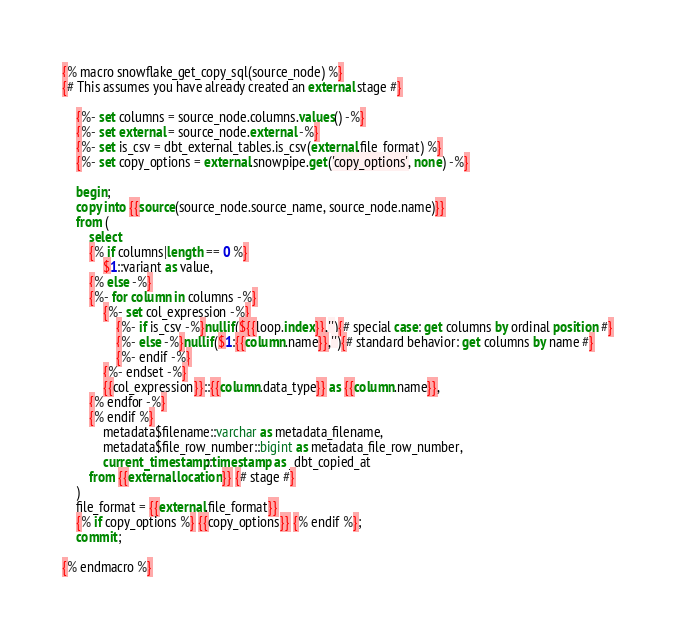<code> <loc_0><loc_0><loc_500><loc_500><_SQL_>{% macro snowflake_get_copy_sql(source_node) %}
{# This assumes you have already created an external stage #}

    {%- set columns = source_node.columns.values() -%}
    {%- set external = source_node.external -%}
    {%- set is_csv = dbt_external_tables.is_csv(external.file_format) %}
    {%- set copy_options = external.snowpipe.get('copy_options', none) -%}
    
    begin;
    copy into {{source(source_node.source_name, source_node.name)}}
    from ( 
        select
        {% if columns|length == 0 %}
            $1::variant as value,
        {% else -%}
        {%- for column in columns -%}
            {%- set col_expression -%}
                {%- if is_csv -%}nullif(${{loop.index}},''){# special case: get columns by ordinal position #}
                {%- else -%}nullif($1:{{column.name}},''){# standard behavior: get columns by name #}
                {%- endif -%}
            {%- endset -%}
            {{col_expression}}::{{column.data_type}} as {{column.name}},
        {% endfor -%}
        {% endif %}
            metadata$filename::varchar as metadata_filename,
            metadata$file_row_number::bigint as metadata_file_row_number,
            current_timestamp::timestamp as _dbt_copied_at
        from {{external.location}} {# stage #}
    )
    file_format = {{external.file_format}}
    {% if copy_options %} {{copy_options}} {% endif %};
    commit;

{% endmacro %}
</code> 